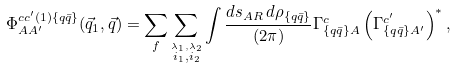<formula> <loc_0><loc_0><loc_500><loc_500>\Phi _ { A A ^ { \prime } } ^ { c c ^ { \prime } ( 1 ) \{ q \bar { q } \} } ( \vec { q } _ { 1 } , \vec { q } ) = \sum _ { f } \sum _ { \stackrel { \lambda _ { 1 } , \lambda _ { 2 } } { i _ { 1 } , i _ { 2 } } } \int \frac { d s _ { A R } \, d \rho _ { \{ q \bar { q } \} } } { ( 2 \pi ) } \Gamma ^ { c } _ { \{ q \bar { q } \} A } \left ( \Gamma ^ { c ^ { \prime } } _ { \{ q \bar { q } \} A ^ { \prime } } \right ) ^ { * } ,</formula> 